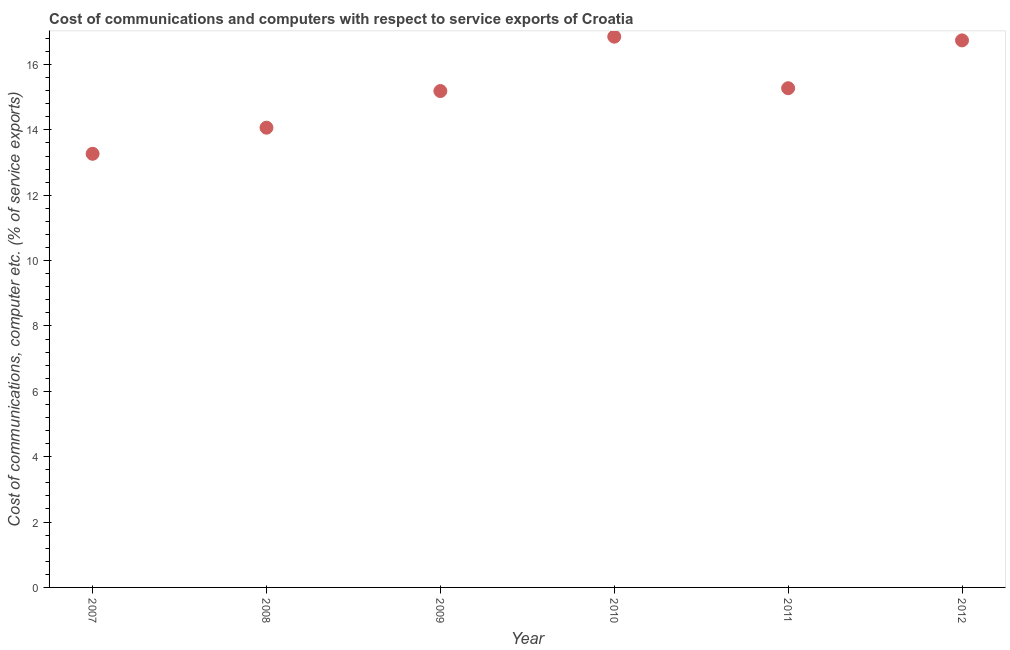What is the cost of communications and computer in 2008?
Keep it short and to the point. 14.07. Across all years, what is the maximum cost of communications and computer?
Ensure brevity in your answer.  16.85. Across all years, what is the minimum cost of communications and computer?
Your answer should be compact. 13.27. In which year was the cost of communications and computer maximum?
Give a very brief answer. 2010. What is the sum of the cost of communications and computer?
Give a very brief answer. 91.39. What is the difference between the cost of communications and computer in 2009 and 2011?
Your response must be concise. -0.09. What is the average cost of communications and computer per year?
Keep it short and to the point. 15.23. What is the median cost of communications and computer?
Your answer should be very brief. 15.23. In how many years, is the cost of communications and computer greater than 6 %?
Your answer should be compact. 6. What is the ratio of the cost of communications and computer in 2008 to that in 2012?
Give a very brief answer. 0.84. Is the cost of communications and computer in 2009 less than that in 2012?
Offer a terse response. Yes. Is the difference between the cost of communications and computer in 2010 and 2012 greater than the difference between any two years?
Provide a succinct answer. No. What is the difference between the highest and the second highest cost of communications and computer?
Keep it short and to the point. 0.11. Is the sum of the cost of communications and computer in 2007 and 2009 greater than the maximum cost of communications and computer across all years?
Make the answer very short. Yes. What is the difference between the highest and the lowest cost of communications and computer?
Your answer should be compact. 3.58. How many dotlines are there?
Your answer should be compact. 1. How many years are there in the graph?
Give a very brief answer. 6. Are the values on the major ticks of Y-axis written in scientific E-notation?
Ensure brevity in your answer.  No. Does the graph contain any zero values?
Your response must be concise. No. What is the title of the graph?
Make the answer very short. Cost of communications and computers with respect to service exports of Croatia. What is the label or title of the Y-axis?
Your response must be concise. Cost of communications, computer etc. (% of service exports). What is the Cost of communications, computer etc. (% of service exports) in 2007?
Keep it short and to the point. 13.27. What is the Cost of communications, computer etc. (% of service exports) in 2008?
Provide a succinct answer. 14.07. What is the Cost of communications, computer etc. (% of service exports) in 2009?
Your answer should be very brief. 15.19. What is the Cost of communications, computer etc. (% of service exports) in 2010?
Your answer should be very brief. 16.85. What is the Cost of communications, computer etc. (% of service exports) in 2011?
Provide a succinct answer. 15.28. What is the Cost of communications, computer etc. (% of service exports) in 2012?
Ensure brevity in your answer.  16.74. What is the difference between the Cost of communications, computer etc. (% of service exports) in 2007 and 2008?
Keep it short and to the point. -0.8. What is the difference between the Cost of communications, computer etc. (% of service exports) in 2007 and 2009?
Offer a terse response. -1.92. What is the difference between the Cost of communications, computer etc. (% of service exports) in 2007 and 2010?
Your answer should be compact. -3.58. What is the difference between the Cost of communications, computer etc. (% of service exports) in 2007 and 2011?
Keep it short and to the point. -2.01. What is the difference between the Cost of communications, computer etc. (% of service exports) in 2007 and 2012?
Keep it short and to the point. -3.47. What is the difference between the Cost of communications, computer etc. (% of service exports) in 2008 and 2009?
Offer a terse response. -1.12. What is the difference between the Cost of communications, computer etc. (% of service exports) in 2008 and 2010?
Provide a short and direct response. -2.78. What is the difference between the Cost of communications, computer etc. (% of service exports) in 2008 and 2011?
Your response must be concise. -1.21. What is the difference between the Cost of communications, computer etc. (% of service exports) in 2008 and 2012?
Provide a short and direct response. -2.67. What is the difference between the Cost of communications, computer etc. (% of service exports) in 2009 and 2010?
Give a very brief answer. -1.66. What is the difference between the Cost of communications, computer etc. (% of service exports) in 2009 and 2011?
Keep it short and to the point. -0.09. What is the difference between the Cost of communications, computer etc. (% of service exports) in 2009 and 2012?
Provide a succinct answer. -1.55. What is the difference between the Cost of communications, computer etc. (% of service exports) in 2010 and 2011?
Keep it short and to the point. 1.58. What is the difference between the Cost of communications, computer etc. (% of service exports) in 2010 and 2012?
Offer a very short reply. 0.11. What is the difference between the Cost of communications, computer etc. (% of service exports) in 2011 and 2012?
Provide a succinct answer. -1.46. What is the ratio of the Cost of communications, computer etc. (% of service exports) in 2007 to that in 2008?
Offer a terse response. 0.94. What is the ratio of the Cost of communications, computer etc. (% of service exports) in 2007 to that in 2009?
Provide a short and direct response. 0.87. What is the ratio of the Cost of communications, computer etc. (% of service exports) in 2007 to that in 2010?
Offer a very short reply. 0.79. What is the ratio of the Cost of communications, computer etc. (% of service exports) in 2007 to that in 2011?
Give a very brief answer. 0.87. What is the ratio of the Cost of communications, computer etc. (% of service exports) in 2007 to that in 2012?
Make the answer very short. 0.79. What is the ratio of the Cost of communications, computer etc. (% of service exports) in 2008 to that in 2009?
Give a very brief answer. 0.93. What is the ratio of the Cost of communications, computer etc. (% of service exports) in 2008 to that in 2010?
Your response must be concise. 0.83. What is the ratio of the Cost of communications, computer etc. (% of service exports) in 2008 to that in 2011?
Provide a short and direct response. 0.92. What is the ratio of the Cost of communications, computer etc. (% of service exports) in 2008 to that in 2012?
Offer a very short reply. 0.84. What is the ratio of the Cost of communications, computer etc. (% of service exports) in 2009 to that in 2010?
Provide a succinct answer. 0.9. What is the ratio of the Cost of communications, computer etc. (% of service exports) in 2009 to that in 2012?
Offer a very short reply. 0.91. What is the ratio of the Cost of communications, computer etc. (% of service exports) in 2010 to that in 2011?
Make the answer very short. 1.1. What is the ratio of the Cost of communications, computer etc. (% of service exports) in 2010 to that in 2012?
Keep it short and to the point. 1.01. What is the ratio of the Cost of communications, computer etc. (% of service exports) in 2011 to that in 2012?
Make the answer very short. 0.91. 